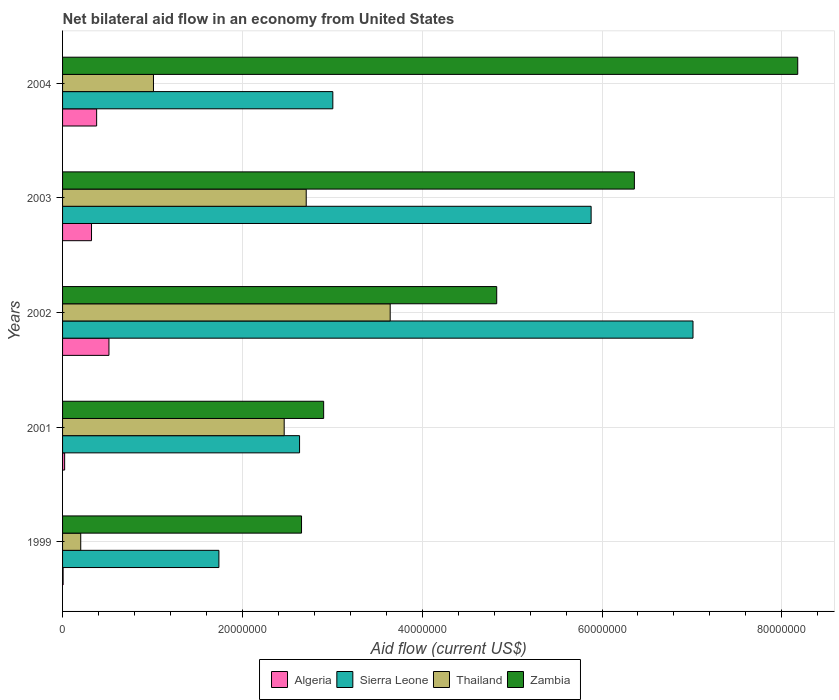How many groups of bars are there?
Make the answer very short. 5. Are the number of bars on each tick of the Y-axis equal?
Offer a terse response. Yes. How many bars are there on the 1st tick from the top?
Your answer should be very brief. 4. How many bars are there on the 5th tick from the bottom?
Offer a very short reply. 4. What is the label of the 1st group of bars from the top?
Make the answer very short. 2004. What is the net bilateral aid flow in Sierra Leone in 1999?
Your response must be concise. 1.74e+07. Across all years, what is the maximum net bilateral aid flow in Zambia?
Offer a very short reply. 8.18e+07. Across all years, what is the minimum net bilateral aid flow in Sierra Leone?
Provide a short and direct response. 1.74e+07. In which year was the net bilateral aid flow in Zambia maximum?
Give a very brief answer. 2004. In which year was the net bilateral aid flow in Zambia minimum?
Offer a very short reply. 1999. What is the total net bilateral aid flow in Algeria in the graph?
Keep it short and to the point. 1.25e+07. What is the difference between the net bilateral aid flow in Zambia in 1999 and that in 2004?
Provide a short and direct response. -5.52e+07. What is the difference between the net bilateral aid flow in Algeria in 2001 and the net bilateral aid flow in Sierra Leone in 1999?
Offer a very short reply. -1.72e+07. What is the average net bilateral aid flow in Algeria per year?
Your answer should be compact. 2.49e+06. In the year 2001, what is the difference between the net bilateral aid flow in Algeria and net bilateral aid flow in Sierra Leone?
Make the answer very short. -2.61e+07. What is the ratio of the net bilateral aid flow in Thailand in 2001 to that in 2003?
Your answer should be very brief. 0.91. Is the net bilateral aid flow in Algeria in 2002 less than that in 2004?
Offer a terse response. No. Is the difference between the net bilateral aid flow in Algeria in 1999 and 2001 greater than the difference between the net bilateral aid flow in Sierra Leone in 1999 and 2001?
Make the answer very short. Yes. What is the difference between the highest and the second highest net bilateral aid flow in Thailand?
Your response must be concise. 9.34e+06. What is the difference between the highest and the lowest net bilateral aid flow in Algeria?
Offer a terse response. 5.10e+06. What does the 3rd bar from the top in 2003 represents?
Offer a terse response. Sierra Leone. What does the 1st bar from the bottom in 2001 represents?
Make the answer very short. Algeria. Are all the bars in the graph horizontal?
Ensure brevity in your answer.  Yes. Does the graph contain any zero values?
Keep it short and to the point. No. Where does the legend appear in the graph?
Your response must be concise. Bottom center. How are the legend labels stacked?
Offer a terse response. Horizontal. What is the title of the graph?
Ensure brevity in your answer.  Net bilateral aid flow in an economy from United States. Does "Senegal" appear as one of the legend labels in the graph?
Provide a succinct answer. No. What is the Aid flow (current US$) in Algeria in 1999?
Keep it short and to the point. 6.00e+04. What is the Aid flow (current US$) of Sierra Leone in 1999?
Your answer should be compact. 1.74e+07. What is the Aid flow (current US$) in Thailand in 1999?
Give a very brief answer. 2.02e+06. What is the Aid flow (current US$) in Zambia in 1999?
Your answer should be compact. 2.66e+07. What is the Aid flow (current US$) of Sierra Leone in 2001?
Provide a succinct answer. 2.64e+07. What is the Aid flow (current US$) in Thailand in 2001?
Your answer should be very brief. 2.46e+07. What is the Aid flow (current US$) of Zambia in 2001?
Provide a short and direct response. 2.90e+07. What is the Aid flow (current US$) of Algeria in 2002?
Give a very brief answer. 5.16e+06. What is the Aid flow (current US$) in Sierra Leone in 2002?
Ensure brevity in your answer.  7.01e+07. What is the Aid flow (current US$) of Thailand in 2002?
Keep it short and to the point. 3.64e+07. What is the Aid flow (current US$) in Zambia in 2002?
Your answer should be very brief. 4.83e+07. What is the Aid flow (current US$) of Algeria in 2003?
Your answer should be very brief. 3.22e+06. What is the Aid flow (current US$) of Sierra Leone in 2003?
Offer a terse response. 5.88e+07. What is the Aid flow (current US$) in Thailand in 2003?
Ensure brevity in your answer.  2.71e+07. What is the Aid flow (current US$) of Zambia in 2003?
Ensure brevity in your answer.  6.36e+07. What is the Aid flow (current US$) in Algeria in 2004?
Your answer should be compact. 3.79e+06. What is the Aid flow (current US$) of Sierra Leone in 2004?
Provide a succinct answer. 3.01e+07. What is the Aid flow (current US$) in Thailand in 2004?
Offer a very short reply. 1.01e+07. What is the Aid flow (current US$) of Zambia in 2004?
Make the answer very short. 8.18e+07. Across all years, what is the maximum Aid flow (current US$) of Algeria?
Keep it short and to the point. 5.16e+06. Across all years, what is the maximum Aid flow (current US$) in Sierra Leone?
Your answer should be compact. 7.01e+07. Across all years, what is the maximum Aid flow (current US$) in Thailand?
Offer a very short reply. 3.64e+07. Across all years, what is the maximum Aid flow (current US$) of Zambia?
Provide a succinct answer. 8.18e+07. Across all years, what is the minimum Aid flow (current US$) of Algeria?
Provide a succinct answer. 6.00e+04. Across all years, what is the minimum Aid flow (current US$) of Sierra Leone?
Your response must be concise. 1.74e+07. Across all years, what is the minimum Aid flow (current US$) of Thailand?
Your answer should be compact. 2.02e+06. Across all years, what is the minimum Aid flow (current US$) of Zambia?
Offer a terse response. 2.66e+07. What is the total Aid flow (current US$) in Algeria in the graph?
Keep it short and to the point. 1.25e+07. What is the total Aid flow (current US$) in Sierra Leone in the graph?
Your response must be concise. 2.03e+08. What is the total Aid flow (current US$) in Thailand in the graph?
Your answer should be compact. 1.00e+08. What is the total Aid flow (current US$) in Zambia in the graph?
Provide a succinct answer. 2.49e+08. What is the difference between the Aid flow (current US$) of Algeria in 1999 and that in 2001?
Your response must be concise. -1.70e+05. What is the difference between the Aid flow (current US$) in Sierra Leone in 1999 and that in 2001?
Your response must be concise. -8.97e+06. What is the difference between the Aid flow (current US$) of Thailand in 1999 and that in 2001?
Keep it short and to the point. -2.26e+07. What is the difference between the Aid flow (current US$) in Zambia in 1999 and that in 2001?
Your answer should be very brief. -2.46e+06. What is the difference between the Aid flow (current US$) of Algeria in 1999 and that in 2002?
Offer a terse response. -5.10e+06. What is the difference between the Aid flow (current US$) in Sierra Leone in 1999 and that in 2002?
Your answer should be compact. -5.27e+07. What is the difference between the Aid flow (current US$) in Thailand in 1999 and that in 2002?
Keep it short and to the point. -3.44e+07. What is the difference between the Aid flow (current US$) of Zambia in 1999 and that in 2002?
Make the answer very short. -2.17e+07. What is the difference between the Aid flow (current US$) of Algeria in 1999 and that in 2003?
Your answer should be very brief. -3.16e+06. What is the difference between the Aid flow (current US$) in Sierra Leone in 1999 and that in 2003?
Your answer should be compact. -4.14e+07. What is the difference between the Aid flow (current US$) in Thailand in 1999 and that in 2003?
Keep it short and to the point. -2.51e+07. What is the difference between the Aid flow (current US$) in Zambia in 1999 and that in 2003?
Make the answer very short. -3.70e+07. What is the difference between the Aid flow (current US$) of Algeria in 1999 and that in 2004?
Make the answer very short. -3.73e+06. What is the difference between the Aid flow (current US$) in Sierra Leone in 1999 and that in 2004?
Offer a terse response. -1.27e+07. What is the difference between the Aid flow (current US$) of Thailand in 1999 and that in 2004?
Offer a terse response. -8.09e+06. What is the difference between the Aid flow (current US$) of Zambia in 1999 and that in 2004?
Make the answer very short. -5.52e+07. What is the difference between the Aid flow (current US$) in Algeria in 2001 and that in 2002?
Give a very brief answer. -4.93e+06. What is the difference between the Aid flow (current US$) in Sierra Leone in 2001 and that in 2002?
Provide a succinct answer. -4.38e+07. What is the difference between the Aid flow (current US$) in Thailand in 2001 and that in 2002?
Your answer should be very brief. -1.18e+07. What is the difference between the Aid flow (current US$) of Zambia in 2001 and that in 2002?
Provide a short and direct response. -1.92e+07. What is the difference between the Aid flow (current US$) in Algeria in 2001 and that in 2003?
Your response must be concise. -2.99e+06. What is the difference between the Aid flow (current US$) of Sierra Leone in 2001 and that in 2003?
Give a very brief answer. -3.24e+07. What is the difference between the Aid flow (current US$) of Thailand in 2001 and that in 2003?
Ensure brevity in your answer.  -2.45e+06. What is the difference between the Aid flow (current US$) of Zambia in 2001 and that in 2003?
Ensure brevity in your answer.  -3.46e+07. What is the difference between the Aid flow (current US$) of Algeria in 2001 and that in 2004?
Make the answer very short. -3.56e+06. What is the difference between the Aid flow (current US$) of Sierra Leone in 2001 and that in 2004?
Offer a very short reply. -3.70e+06. What is the difference between the Aid flow (current US$) of Thailand in 2001 and that in 2004?
Provide a succinct answer. 1.45e+07. What is the difference between the Aid flow (current US$) in Zambia in 2001 and that in 2004?
Offer a terse response. -5.27e+07. What is the difference between the Aid flow (current US$) of Algeria in 2002 and that in 2003?
Your response must be concise. 1.94e+06. What is the difference between the Aid flow (current US$) of Sierra Leone in 2002 and that in 2003?
Your response must be concise. 1.13e+07. What is the difference between the Aid flow (current US$) in Thailand in 2002 and that in 2003?
Your response must be concise. 9.34e+06. What is the difference between the Aid flow (current US$) in Zambia in 2002 and that in 2003?
Provide a short and direct response. -1.53e+07. What is the difference between the Aid flow (current US$) of Algeria in 2002 and that in 2004?
Your answer should be compact. 1.37e+06. What is the difference between the Aid flow (current US$) of Sierra Leone in 2002 and that in 2004?
Offer a very short reply. 4.01e+07. What is the difference between the Aid flow (current US$) in Thailand in 2002 and that in 2004?
Make the answer very short. 2.63e+07. What is the difference between the Aid flow (current US$) of Zambia in 2002 and that in 2004?
Your response must be concise. -3.35e+07. What is the difference between the Aid flow (current US$) of Algeria in 2003 and that in 2004?
Your answer should be compact. -5.70e+05. What is the difference between the Aid flow (current US$) of Sierra Leone in 2003 and that in 2004?
Ensure brevity in your answer.  2.87e+07. What is the difference between the Aid flow (current US$) in Thailand in 2003 and that in 2004?
Offer a very short reply. 1.70e+07. What is the difference between the Aid flow (current US$) of Zambia in 2003 and that in 2004?
Offer a terse response. -1.82e+07. What is the difference between the Aid flow (current US$) of Algeria in 1999 and the Aid flow (current US$) of Sierra Leone in 2001?
Provide a succinct answer. -2.63e+07. What is the difference between the Aid flow (current US$) in Algeria in 1999 and the Aid flow (current US$) in Thailand in 2001?
Provide a succinct answer. -2.46e+07. What is the difference between the Aid flow (current US$) in Algeria in 1999 and the Aid flow (current US$) in Zambia in 2001?
Your response must be concise. -2.90e+07. What is the difference between the Aid flow (current US$) of Sierra Leone in 1999 and the Aid flow (current US$) of Thailand in 2001?
Make the answer very short. -7.26e+06. What is the difference between the Aid flow (current US$) in Sierra Leone in 1999 and the Aid flow (current US$) in Zambia in 2001?
Offer a very short reply. -1.16e+07. What is the difference between the Aid flow (current US$) in Thailand in 1999 and the Aid flow (current US$) in Zambia in 2001?
Provide a succinct answer. -2.70e+07. What is the difference between the Aid flow (current US$) of Algeria in 1999 and the Aid flow (current US$) of Sierra Leone in 2002?
Make the answer very short. -7.01e+07. What is the difference between the Aid flow (current US$) of Algeria in 1999 and the Aid flow (current US$) of Thailand in 2002?
Give a very brief answer. -3.64e+07. What is the difference between the Aid flow (current US$) in Algeria in 1999 and the Aid flow (current US$) in Zambia in 2002?
Offer a very short reply. -4.82e+07. What is the difference between the Aid flow (current US$) in Sierra Leone in 1999 and the Aid flow (current US$) in Thailand in 2002?
Provide a short and direct response. -1.90e+07. What is the difference between the Aid flow (current US$) of Sierra Leone in 1999 and the Aid flow (current US$) of Zambia in 2002?
Offer a terse response. -3.09e+07. What is the difference between the Aid flow (current US$) of Thailand in 1999 and the Aid flow (current US$) of Zambia in 2002?
Your answer should be compact. -4.63e+07. What is the difference between the Aid flow (current US$) of Algeria in 1999 and the Aid flow (current US$) of Sierra Leone in 2003?
Offer a very short reply. -5.87e+07. What is the difference between the Aid flow (current US$) in Algeria in 1999 and the Aid flow (current US$) in Thailand in 2003?
Your answer should be very brief. -2.70e+07. What is the difference between the Aid flow (current US$) of Algeria in 1999 and the Aid flow (current US$) of Zambia in 2003?
Your answer should be very brief. -6.35e+07. What is the difference between the Aid flow (current US$) in Sierra Leone in 1999 and the Aid flow (current US$) in Thailand in 2003?
Offer a terse response. -9.71e+06. What is the difference between the Aid flow (current US$) of Sierra Leone in 1999 and the Aid flow (current US$) of Zambia in 2003?
Offer a very short reply. -4.62e+07. What is the difference between the Aid flow (current US$) in Thailand in 1999 and the Aid flow (current US$) in Zambia in 2003?
Provide a short and direct response. -6.16e+07. What is the difference between the Aid flow (current US$) of Algeria in 1999 and the Aid flow (current US$) of Sierra Leone in 2004?
Make the answer very short. -3.00e+07. What is the difference between the Aid flow (current US$) of Algeria in 1999 and the Aid flow (current US$) of Thailand in 2004?
Keep it short and to the point. -1.00e+07. What is the difference between the Aid flow (current US$) of Algeria in 1999 and the Aid flow (current US$) of Zambia in 2004?
Offer a very short reply. -8.17e+07. What is the difference between the Aid flow (current US$) in Sierra Leone in 1999 and the Aid flow (current US$) in Thailand in 2004?
Your response must be concise. 7.28e+06. What is the difference between the Aid flow (current US$) in Sierra Leone in 1999 and the Aid flow (current US$) in Zambia in 2004?
Provide a succinct answer. -6.44e+07. What is the difference between the Aid flow (current US$) in Thailand in 1999 and the Aid flow (current US$) in Zambia in 2004?
Ensure brevity in your answer.  -7.98e+07. What is the difference between the Aid flow (current US$) of Algeria in 2001 and the Aid flow (current US$) of Sierra Leone in 2002?
Give a very brief answer. -6.99e+07. What is the difference between the Aid flow (current US$) in Algeria in 2001 and the Aid flow (current US$) in Thailand in 2002?
Offer a terse response. -3.62e+07. What is the difference between the Aid flow (current US$) in Algeria in 2001 and the Aid flow (current US$) in Zambia in 2002?
Ensure brevity in your answer.  -4.81e+07. What is the difference between the Aid flow (current US$) in Sierra Leone in 2001 and the Aid flow (current US$) in Thailand in 2002?
Provide a short and direct response. -1.01e+07. What is the difference between the Aid flow (current US$) in Sierra Leone in 2001 and the Aid flow (current US$) in Zambia in 2002?
Make the answer very short. -2.19e+07. What is the difference between the Aid flow (current US$) of Thailand in 2001 and the Aid flow (current US$) of Zambia in 2002?
Your answer should be compact. -2.36e+07. What is the difference between the Aid flow (current US$) in Algeria in 2001 and the Aid flow (current US$) in Sierra Leone in 2003?
Offer a very short reply. -5.86e+07. What is the difference between the Aid flow (current US$) of Algeria in 2001 and the Aid flow (current US$) of Thailand in 2003?
Offer a terse response. -2.69e+07. What is the difference between the Aid flow (current US$) in Algeria in 2001 and the Aid flow (current US$) in Zambia in 2003?
Your answer should be very brief. -6.34e+07. What is the difference between the Aid flow (current US$) of Sierra Leone in 2001 and the Aid flow (current US$) of Thailand in 2003?
Provide a short and direct response. -7.40e+05. What is the difference between the Aid flow (current US$) of Sierra Leone in 2001 and the Aid flow (current US$) of Zambia in 2003?
Your answer should be very brief. -3.72e+07. What is the difference between the Aid flow (current US$) of Thailand in 2001 and the Aid flow (current US$) of Zambia in 2003?
Give a very brief answer. -3.90e+07. What is the difference between the Aid flow (current US$) of Algeria in 2001 and the Aid flow (current US$) of Sierra Leone in 2004?
Give a very brief answer. -2.98e+07. What is the difference between the Aid flow (current US$) of Algeria in 2001 and the Aid flow (current US$) of Thailand in 2004?
Offer a very short reply. -9.88e+06. What is the difference between the Aid flow (current US$) of Algeria in 2001 and the Aid flow (current US$) of Zambia in 2004?
Give a very brief answer. -8.15e+07. What is the difference between the Aid flow (current US$) in Sierra Leone in 2001 and the Aid flow (current US$) in Thailand in 2004?
Provide a succinct answer. 1.62e+07. What is the difference between the Aid flow (current US$) in Sierra Leone in 2001 and the Aid flow (current US$) in Zambia in 2004?
Give a very brief answer. -5.54e+07. What is the difference between the Aid flow (current US$) of Thailand in 2001 and the Aid flow (current US$) of Zambia in 2004?
Your answer should be very brief. -5.71e+07. What is the difference between the Aid flow (current US$) in Algeria in 2002 and the Aid flow (current US$) in Sierra Leone in 2003?
Your response must be concise. -5.36e+07. What is the difference between the Aid flow (current US$) of Algeria in 2002 and the Aid flow (current US$) of Thailand in 2003?
Your answer should be very brief. -2.19e+07. What is the difference between the Aid flow (current US$) in Algeria in 2002 and the Aid flow (current US$) in Zambia in 2003?
Provide a succinct answer. -5.84e+07. What is the difference between the Aid flow (current US$) of Sierra Leone in 2002 and the Aid flow (current US$) of Thailand in 2003?
Your response must be concise. 4.30e+07. What is the difference between the Aid flow (current US$) of Sierra Leone in 2002 and the Aid flow (current US$) of Zambia in 2003?
Give a very brief answer. 6.52e+06. What is the difference between the Aid flow (current US$) of Thailand in 2002 and the Aid flow (current US$) of Zambia in 2003?
Your answer should be very brief. -2.72e+07. What is the difference between the Aid flow (current US$) of Algeria in 2002 and the Aid flow (current US$) of Sierra Leone in 2004?
Your response must be concise. -2.49e+07. What is the difference between the Aid flow (current US$) of Algeria in 2002 and the Aid flow (current US$) of Thailand in 2004?
Give a very brief answer. -4.95e+06. What is the difference between the Aid flow (current US$) in Algeria in 2002 and the Aid flow (current US$) in Zambia in 2004?
Give a very brief answer. -7.66e+07. What is the difference between the Aid flow (current US$) of Sierra Leone in 2002 and the Aid flow (current US$) of Thailand in 2004?
Provide a succinct answer. 6.00e+07. What is the difference between the Aid flow (current US$) in Sierra Leone in 2002 and the Aid flow (current US$) in Zambia in 2004?
Give a very brief answer. -1.16e+07. What is the difference between the Aid flow (current US$) in Thailand in 2002 and the Aid flow (current US$) in Zambia in 2004?
Provide a succinct answer. -4.53e+07. What is the difference between the Aid flow (current US$) in Algeria in 2003 and the Aid flow (current US$) in Sierra Leone in 2004?
Your answer should be compact. -2.68e+07. What is the difference between the Aid flow (current US$) in Algeria in 2003 and the Aid flow (current US$) in Thailand in 2004?
Offer a very short reply. -6.89e+06. What is the difference between the Aid flow (current US$) in Algeria in 2003 and the Aid flow (current US$) in Zambia in 2004?
Your answer should be compact. -7.86e+07. What is the difference between the Aid flow (current US$) of Sierra Leone in 2003 and the Aid flow (current US$) of Thailand in 2004?
Give a very brief answer. 4.87e+07. What is the difference between the Aid flow (current US$) of Sierra Leone in 2003 and the Aid flow (current US$) of Zambia in 2004?
Provide a short and direct response. -2.30e+07. What is the difference between the Aid flow (current US$) in Thailand in 2003 and the Aid flow (current US$) in Zambia in 2004?
Offer a very short reply. -5.47e+07. What is the average Aid flow (current US$) in Algeria per year?
Offer a terse response. 2.49e+06. What is the average Aid flow (current US$) of Sierra Leone per year?
Your answer should be compact. 4.05e+07. What is the average Aid flow (current US$) of Thailand per year?
Make the answer very short. 2.01e+07. What is the average Aid flow (current US$) of Zambia per year?
Offer a very short reply. 4.99e+07. In the year 1999, what is the difference between the Aid flow (current US$) in Algeria and Aid flow (current US$) in Sierra Leone?
Provide a succinct answer. -1.73e+07. In the year 1999, what is the difference between the Aid flow (current US$) in Algeria and Aid flow (current US$) in Thailand?
Ensure brevity in your answer.  -1.96e+06. In the year 1999, what is the difference between the Aid flow (current US$) of Algeria and Aid flow (current US$) of Zambia?
Make the answer very short. -2.65e+07. In the year 1999, what is the difference between the Aid flow (current US$) of Sierra Leone and Aid flow (current US$) of Thailand?
Give a very brief answer. 1.54e+07. In the year 1999, what is the difference between the Aid flow (current US$) of Sierra Leone and Aid flow (current US$) of Zambia?
Offer a terse response. -9.19e+06. In the year 1999, what is the difference between the Aid flow (current US$) in Thailand and Aid flow (current US$) in Zambia?
Ensure brevity in your answer.  -2.46e+07. In the year 2001, what is the difference between the Aid flow (current US$) in Algeria and Aid flow (current US$) in Sierra Leone?
Offer a terse response. -2.61e+07. In the year 2001, what is the difference between the Aid flow (current US$) of Algeria and Aid flow (current US$) of Thailand?
Ensure brevity in your answer.  -2.44e+07. In the year 2001, what is the difference between the Aid flow (current US$) in Algeria and Aid flow (current US$) in Zambia?
Your answer should be very brief. -2.88e+07. In the year 2001, what is the difference between the Aid flow (current US$) of Sierra Leone and Aid flow (current US$) of Thailand?
Offer a very short reply. 1.71e+06. In the year 2001, what is the difference between the Aid flow (current US$) in Sierra Leone and Aid flow (current US$) in Zambia?
Ensure brevity in your answer.  -2.68e+06. In the year 2001, what is the difference between the Aid flow (current US$) of Thailand and Aid flow (current US$) of Zambia?
Offer a terse response. -4.39e+06. In the year 2002, what is the difference between the Aid flow (current US$) in Algeria and Aid flow (current US$) in Sierra Leone?
Provide a succinct answer. -6.50e+07. In the year 2002, what is the difference between the Aid flow (current US$) of Algeria and Aid flow (current US$) of Thailand?
Provide a succinct answer. -3.13e+07. In the year 2002, what is the difference between the Aid flow (current US$) in Algeria and Aid flow (current US$) in Zambia?
Your response must be concise. -4.31e+07. In the year 2002, what is the difference between the Aid flow (current US$) in Sierra Leone and Aid flow (current US$) in Thailand?
Make the answer very short. 3.37e+07. In the year 2002, what is the difference between the Aid flow (current US$) of Sierra Leone and Aid flow (current US$) of Zambia?
Provide a short and direct response. 2.18e+07. In the year 2002, what is the difference between the Aid flow (current US$) in Thailand and Aid flow (current US$) in Zambia?
Offer a terse response. -1.18e+07. In the year 2003, what is the difference between the Aid flow (current US$) of Algeria and Aid flow (current US$) of Sierra Leone?
Give a very brief answer. -5.56e+07. In the year 2003, what is the difference between the Aid flow (current US$) in Algeria and Aid flow (current US$) in Thailand?
Give a very brief answer. -2.39e+07. In the year 2003, what is the difference between the Aid flow (current US$) of Algeria and Aid flow (current US$) of Zambia?
Ensure brevity in your answer.  -6.04e+07. In the year 2003, what is the difference between the Aid flow (current US$) in Sierra Leone and Aid flow (current US$) in Thailand?
Make the answer very short. 3.17e+07. In the year 2003, what is the difference between the Aid flow (current US$) of Sierra Leone and Aid flow (current US$) of Zambia?
Provide a succinct answer. -4.81e+06. In the year 2003, what is the difference between the Aid flow (current US$) of Thailand and Aid flow (current US$) of Zambia?
Give a very brief answer. -3.65e+07. In the year 2004, what is the difference between the Aid flow (current US$) in Algeria and Aid flow (current US$) in Sierra Leone?
Keep it short and to the point. -2.63e+07. In the year 2004, what is the difference between the Aid flow (current US$) in Algeria and Aid flow (current US$) in Thailand?
Your answer should be compact. -6.32e+06. In the year 2004, what is the difference between the Aid flow (current US$) in Algeria and Aid flow (current US$) in Zambia?
Offer a terse response. -7.80e+07. In the year 2004, what is the difference between the Aid flow (current US$) of Sierra Leone and Aid flow (current US$) of Thailand?
Your answer should be compact. 2.00e+07. In the year 2004, what is the difference between the Aid flow (current US$) of Sierra Leone and Aid flow (current US$) of Zambia?
Your response must be concise. -5.17e+07. In the year 2004, what is the difference between the Aid flow (current US$) of Thailand and Aid flow (current US$) of Zambia?
Make the answer very short. -7.17e+07. What is the ratio of the Aid flow (current US$) in Algeria in 1999 to that in 2001?
Offer a terse response. 0.26. What is the ratio of the Aid flow (current US$) of Sierra Leone in 1999 to that in 2001?
Provide a short and direct response. 0.66. What is the ratio of the Aid flow (current US$) of Thailand in 1999 to that in 2001?
Offer a very short reply. 0.08. What is the ratio of the Aid flow (current US$) in Zambia in 1999 to that in 2001?
Your response must be concise. 0.92. What is the ratio of the Aid flow (current US$) in Algeria in 1999 to that in 2002?
Your response must be concise. 0.01. What is the ratio of the Aid flow (current US$) of Sierra Leone in 1999 to that in 2002?
Your answer should be compact. 0.25. What is the ratio of the Aid flow (current US$) of Thailand in 1999 to that in 2002?
Ensure brevity in your answer.  0.06. What is the ratio of the Aid flow (current US$) in Zambia in 1999 to that in 2002?
Offer a very short reply. 0.55. What is the ratio of the Aid flow (current US$) of Algeria in 1999 to that in 2003?
Offer a very short reply. 0.02. What is the ratio of the Aid flow (current US$) in Sierra Leone in 1999 to that in 2003?
Make the answer very short. 0.3. What is the ratio of the Aid flow (current US$) of Thailand in 1999 to that in 2003?
Offer a terse response. 0.07. What is the ratio of the Aid flow (current US$) of Zambia in 1999 to that in 2003?
Provide a succinct answer. 0.42. What is the ratio of the Aid flow (current US$) of Algeria in 1999 to that in 2004?
Your response must be concise. 0.02. What is the ratio of the Aid flow (current US$) of Sierra Leone in 1999 to that in 2004?
Provide a succinct answer. 0.58. What is the ratio of the Aid flow (current US$) of Thailand in 1999 to that in 2004?
Make the answer very short. 0.2. What is the ratio of the Aid flow (current US$) in Zambia in 1999 to that in 2004?
Provide a short and direct response. 0.33. What is the ratio of the Aid flow (current US$) in Algeria in 2001 to that in 2002?
Make the answer very short. 0.04. What is the ratio of the Aid flow (current US$) in Sierra Leone in 2001 to that in 2002?
Your answer should be very brief. 0.38. What is the ratio of the Aid flow (current US$) in Thailand in 2001 to that in 2002?
Provide a succinct answer. 0.68. What is the ratio of the Aid flow (current US$) in Zambia in 2001 to that in 2002?
Your answer should be very brief. 0.6. What is the ratio of the Aid flow (current US$) of Algeria in 2001 to that in 2003?
Ensure brevity in your answer.  0.07. What is the ratio of the Aid flow (current US$) in Sierra Leone in 2001 to that in 2003?
Make the answer very short. 0.45. What is the ratio of the Aid flow (current US$) in Thailand in 2001 to that in 2003?
Provide a short and direct response. 0.91. What is the ratio of the Aid flow (current US$) in Zambia in 2001 to that in 2003?
Keep it short and to the point. 0.46. What is the ratio of the Aid flow (current US$) in Algeria in 2001 to that in 2004?
Your answer should be very brief. 0.06. What is the ratio of the Aid flow (current US$) of Sierra Leone in 2001 to that in 2004?
Ensure brevity in your answer.  0.88. What is the ratio of the Aid flow (current US$) of Thailand in 2001 to that in 2004?
Your answer should be very brief. 2.44. What is the ratio of the Aid flow (current US$) in Zambia in 2001 to that in 2004?
Provide a succinct answer. 0.36. What is the ratio of the Aid flow (current US$) of Algeria in 2002 to that in 2003?
Give a very brief answer. 1.6. What is the ratio of the Aid flow (current US$) in Sierra Leone in 2002 to that in 2003?
Provide a succinct answer. 1.19. What is the ratio of the Aid flow (current US$) of Thailand in 2002 to that in 2003?
Your answer should be compact. 1.34. What is the ratio of the Aid flow (current US$) of Zambia in 2002 to that in 2003?
Provide a short and direct response. 0.76. What is the ratio of the Aid flow (current US$) in Algeria in 2002 to that in 2004?
Your response must be concise. 1.36. What is the ratio of the Aid flow (current US$) in Sierra Leone in 2002 to that in 2004?
Offer a very short reply. 2.33. What is the ratio of the Aid flow (current US$) in Thailand in 2002 to that in 2004?
Make the answer very short. 3.6. What is the ratio of the Aid flow (current US$) of Zambia in 2002 to that in 2004?
Provide a short and direct response. 0.59. What is the ratio of the Aid flow (current US$) in Algeria in 2003 to that in 2004?
Your answer should be compact. 0.85. What is the ratio of the Aid flow (current US$) of Sierra Leone in 2003 to that in 2004?
Ensure brevity in your answer.  1.96. What is the ratio of the Aid flow (current US$) in Thailand in 2003 to that in 2004?
Provide a succinct answer. 2.68. What is the difference between the highest and the second highest Aid flow (current US$) of Algeria?
Offer a terse response. 1.37e+06. What is the difference between the highest and the second highest Aid flow (current US$) of Sierra Leone?
Offer a terse response. 1.13e+07. What is the difference between the highest and the second highest Aid flow (current US$) in Thailand?
Your answer should be very brief. 9.34e+06. What is the difference between the highest and the second highest Aid flow (current US$) in Zambia?
Keep it short and to the point. 1.82e+07. What is the difference between the highest and the lowest Aid flow (current US$) in Algeria?
Give a very brief answer. 5.10e+06. What is the difference between the highest and the lowest Aid flow (current US$) in Sierra Leone?
Give a very brief answer. 5.27e+07. What is the difference between the highest and the lowest Aid flow (current US$) in Thailand?
Provide a short and direct response. 3.44e+07. What is the difference between the highest and the lowest Aid flow (current US$) in Zambia?
Your answer should be very brief. 5.52e+07. 